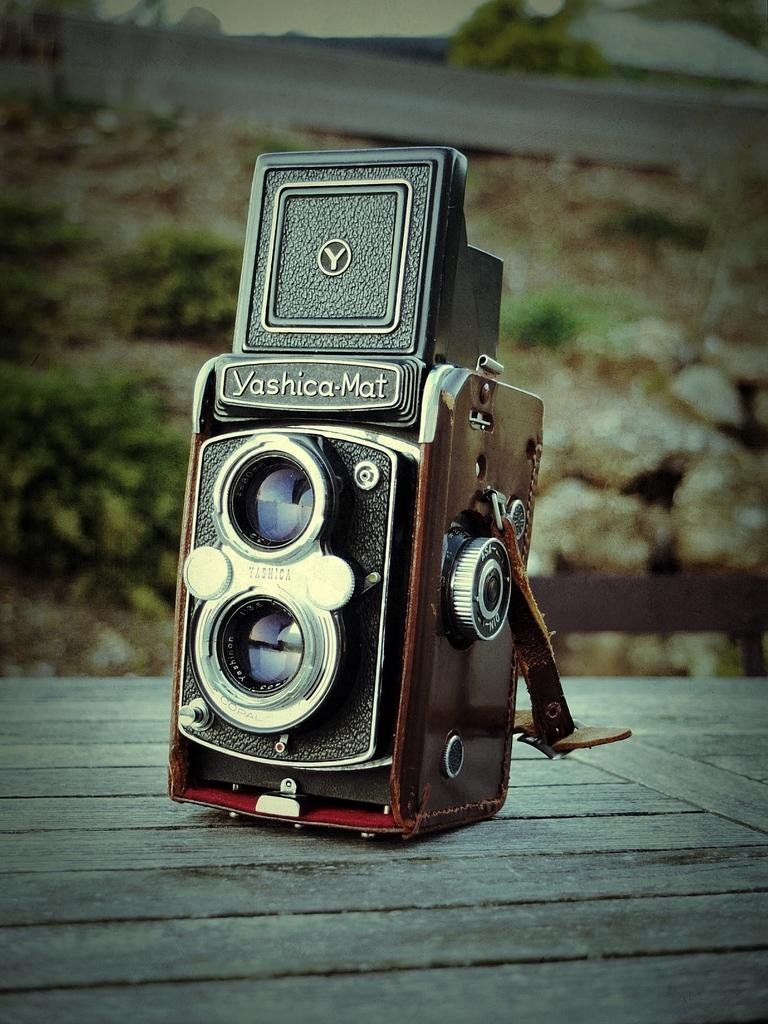What is the main object in the image? There is a camera in the image. Where is the camera located in the image? The camera is in the front of the image. What type of surface is at the bottom of the image? There is a wooden surface at the bottom of the image. What can be seen in the background of the image? There are plants visible in the background of the image. What type of gold jewelry is the camera wearing in the image? There is no gold jewelry or any indication of jewelry on the camera in the image. 